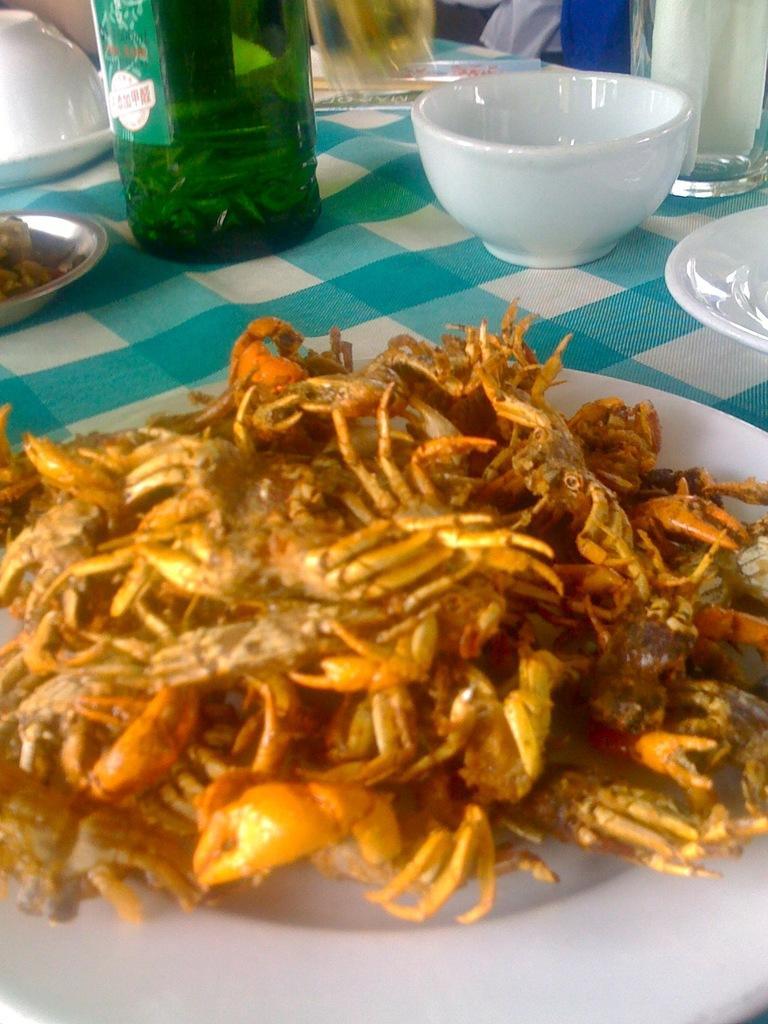Please provide a concise description of this image. In this image their is a plate full of crabs which is kept on the table. On the table there are bowls,glass bottle,plate,glass. 